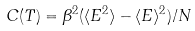Convert formula to latex. <formula><loc_0><loc_0><loc_500><loc_500>C ( T ) = \beta ^ { 2 } ( \langle E ^ { 2 } \rangle - \langle E \rangle ^ { 2 } ) / N</formula> 